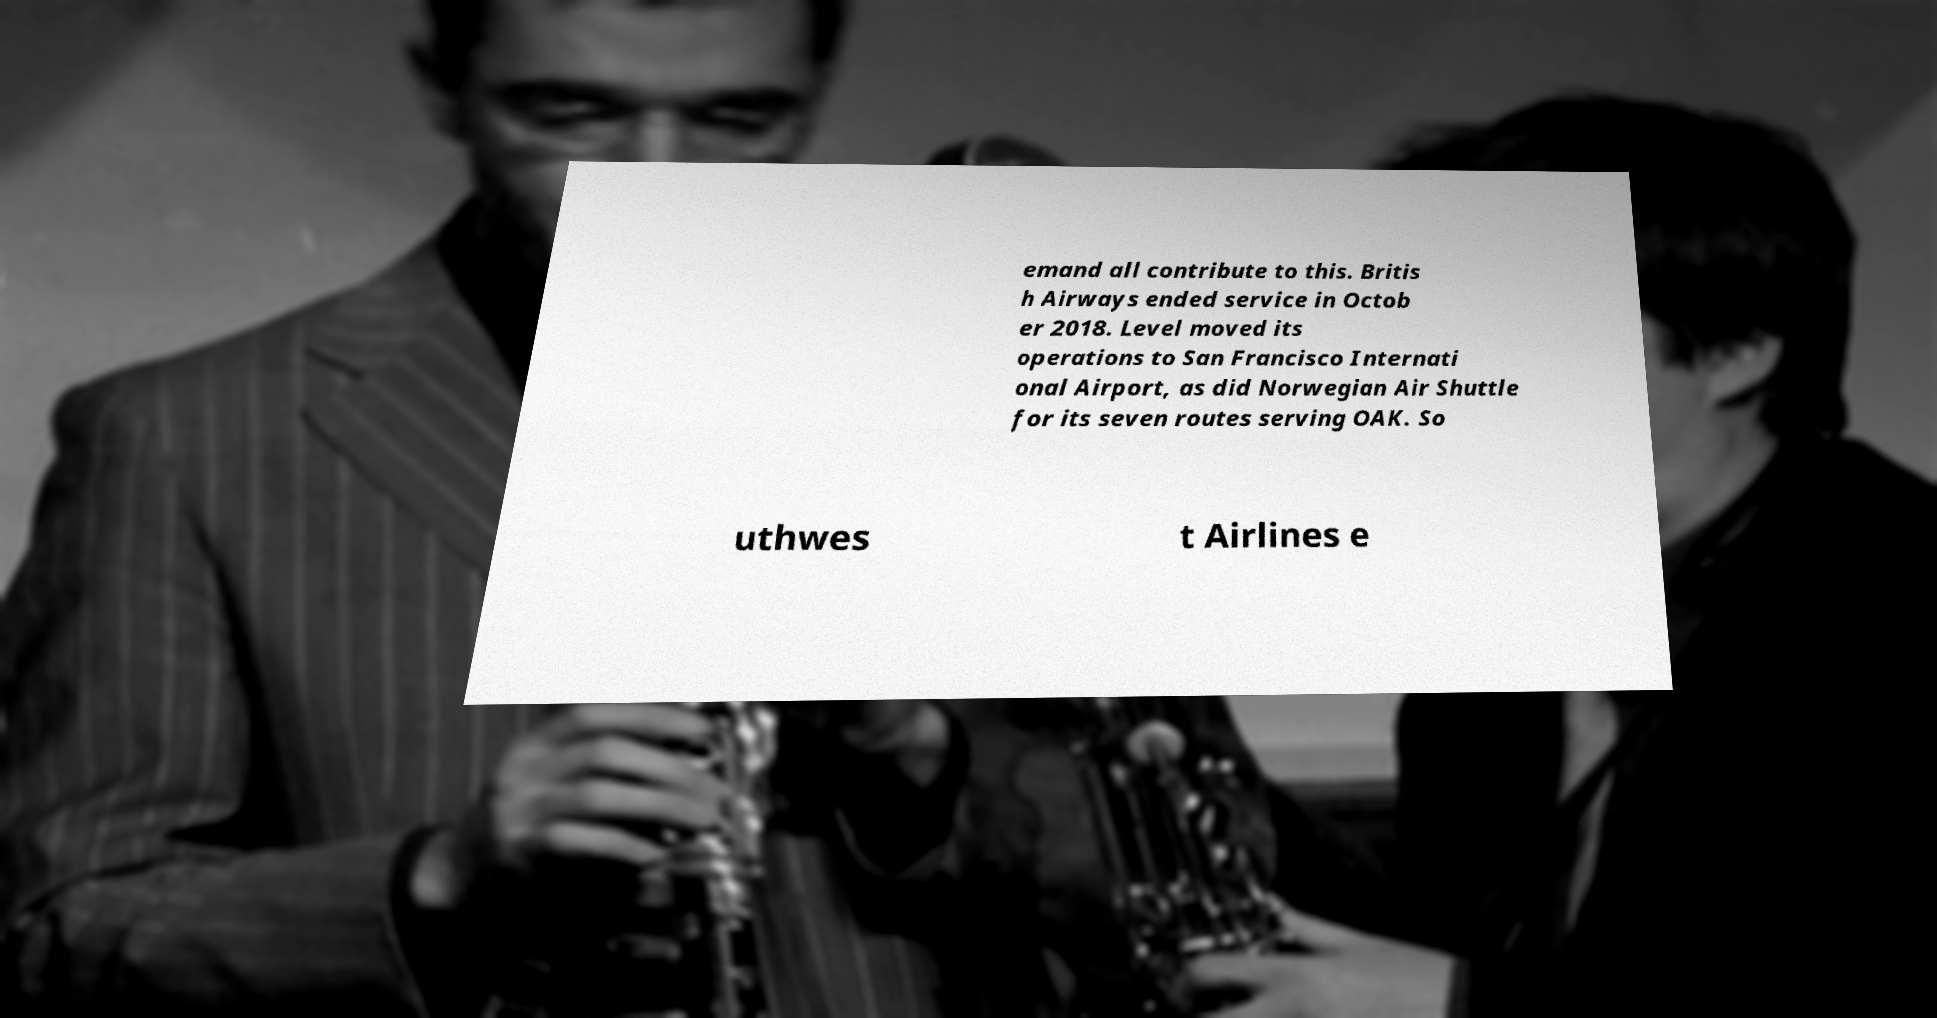Can you read and provide the text displayed in the image?This photo seems to have some interesting text. Can you extract and type it out for me? emand all contribute to this. Britis h Airways ended service in Octob er 2018. Level moved its operations to San Francisco Internati onal Airport, as did Norwegian Air Shuttle for its seven routes serving OAK. So uthwes t Airlines e 